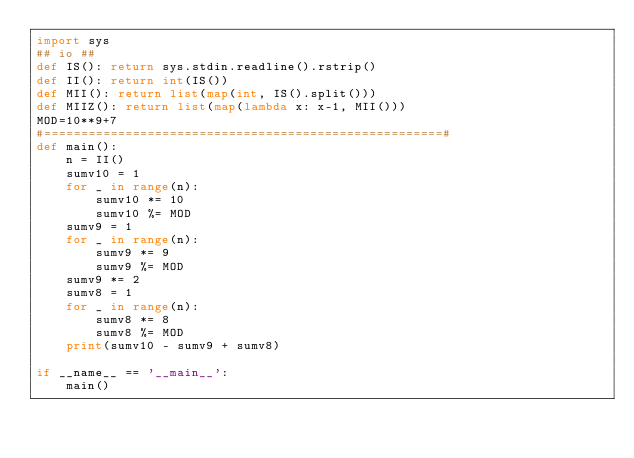<code> <loc_0><loc_0><loc_500><loc_500><_Python_>import sys
## io ##
def IS(): return sys.stdin.readline().rstrip()
def II(): return int(IS())
def MII(): return list(map(int, IS().split()))
def MIIZ(): return list(map(lambda x: x-1, MII()))
MOD=10**9+7
#======================================================#
def main():
    n = II()
    sumv10 = 1
    for _ in range(n):
        sumv10 *= 10
        sumv10 %= MOD
    sumv9 = 1
    for _ in range(n):
        sumv9 *= 9
        sumv9 %= MOD
    sumv9 *= 2
    sumv8 = 1
    for _ in range(n):
        sumv8 *= 8
        sumv8 %= MOD
    print(sumv10 - sumv9 + sumv8)

if __name__ == '__main__':
    main()</code> 